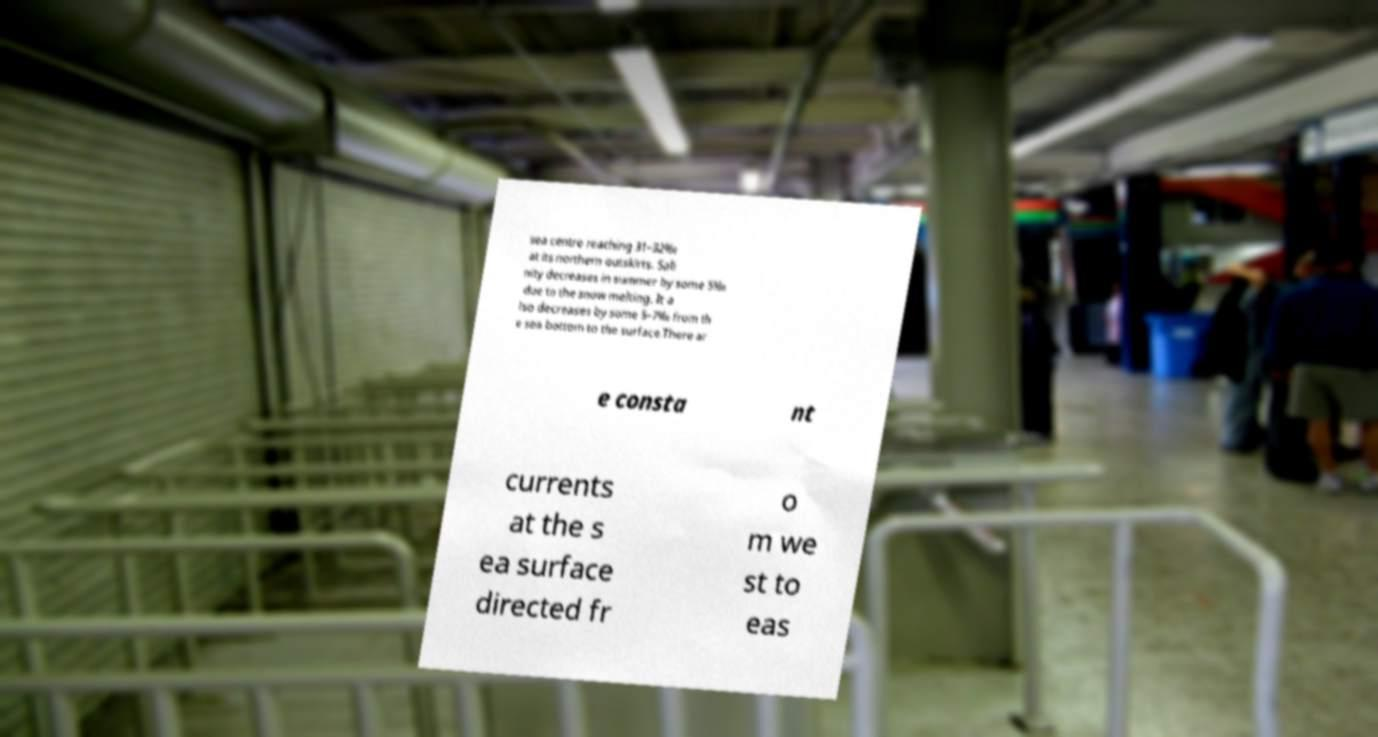What messages or text are displayed in this image? I need them in a readable, typed format. sea centre reaching 31–32‰ at its northern outskirts. Sali nity decreases in summer by some 5‰ due to the snow melting. It a lso decreases by some 5–7‰ from th e sea bottom to the surface.There ar e consta nt currents at the s ea surface directed fr o m we st to eas 